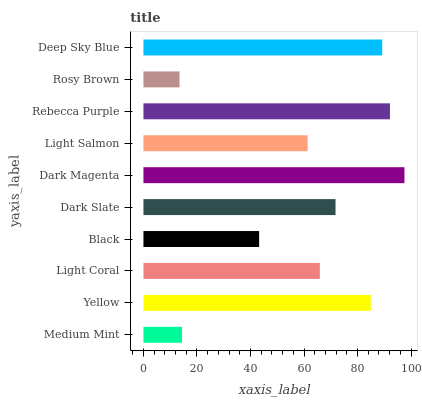Is Rosy Brown the minimum?
Answer yes or no. Yes. Is Dark Magenta the maximum?
Answer yes or no. Yes. Is Yellow the minimum?
Answer yes or no. No. Is Yellow the maximum?
Answer yes or no. No. Is Yellow greater than Medium Mint?
Answer yes or no. Yes. Is Medium Mint less than Yellow?
Answer yes or no. Yes. Is Medium Mint greater than Yellow?
Answer yes or no. No. Is Yellow less than Medium Mint?
Answer yes or no. No. Is Dark Slate the high median?
Answer yes or no. Yes. Is Light Coral the low median?
Answer yes or no. Yes. Is Deep Sky Blue the high median?
Answer yes or no. No. Is Medium Mint the low median?
Answer yes or no. No. 